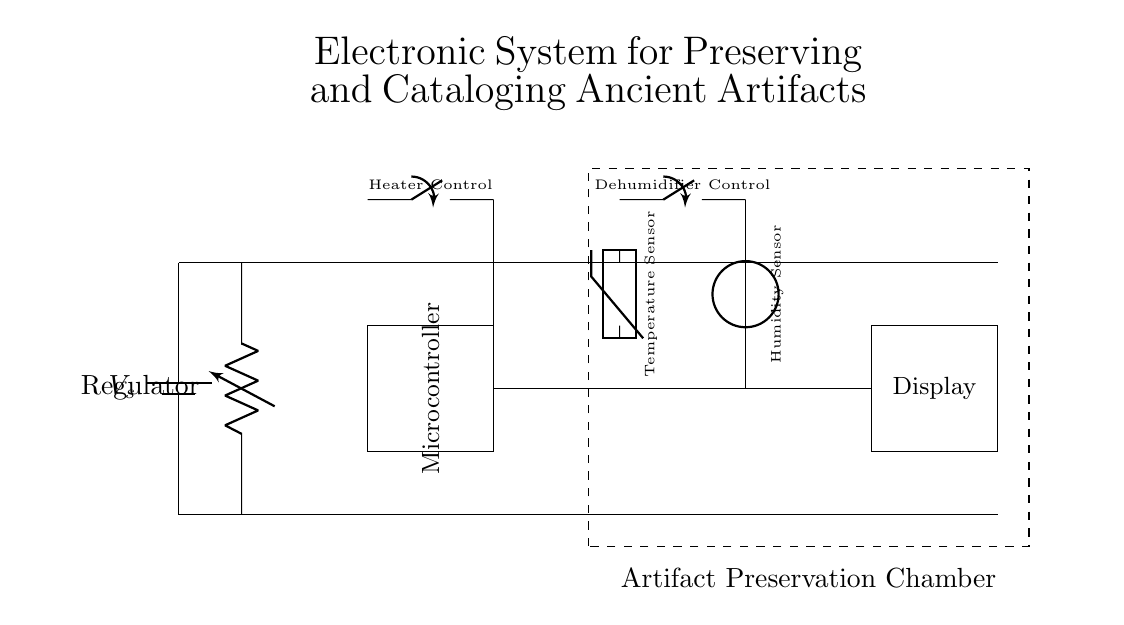What is the main power supply component in this circuit? The main power supply component is the battery, as it provides the necessary voltage to the entire circuit. It is depicted at the leftmost part of the diagram.
Answer: battery What is the function of the voltage regulator? The voltage regulator's function is to maintain a constant output voltage regardless of variations in input voltage or load conditions, ensuring the circuit operates safely and efficiently.
Answer: regulate voltage How many sensors are present in the circuit? There are two sensors depicted in the circuit: the temperature sensor and the humidity sensor, located on the right side.
Answer: two What does the dashed box represent? The dashed box represents the "Artifact Preservation Chamber," indicating the area where the conditions (like temperature and humidity) are controlled to preserve artifacts.
Answer: Artifact Preservation Chamber What is depicted by the switching components in the diagram? The switching components in the diagram act as controls for the heater and dehumidifier systems, allowing them to be turned on or off as needed to maintain optimal preservation conditions.
Answer: heater and dehumidifier controls What is the purpose of the microcontroller within the system? The microcontroller processes data from the sensors and controls other components such as the heater and dehumidifier based on the detected temperature and humidity levels.
Answer: control system 